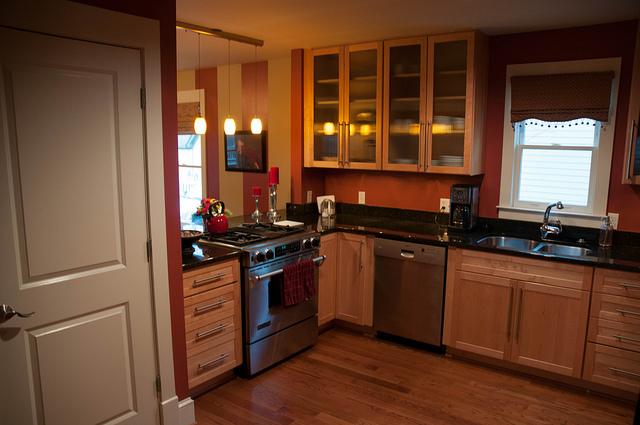Are these kitchen cabinets empty?
Be succinct. No. What is the white object in the corner?
Be succinct. Door. Is there a plant in the kitchen?
Keep it brief. No. Are there curtains on the window?
Write a very short answer. Yes. What type of room is this?
Keep it brief. Kitchen. Does this photo contain a mixture of natural and artificial lighting?
Keep it brief. Yes. What color are the cupboards in this photo?
Answer briefly. Brown. How many ovens does this kitchen have?
Give a very brief answer. 1. Does this room have white cabinets?
Quick response, please. No. Is the kitchen empty?
Answer briefly. Yes. 